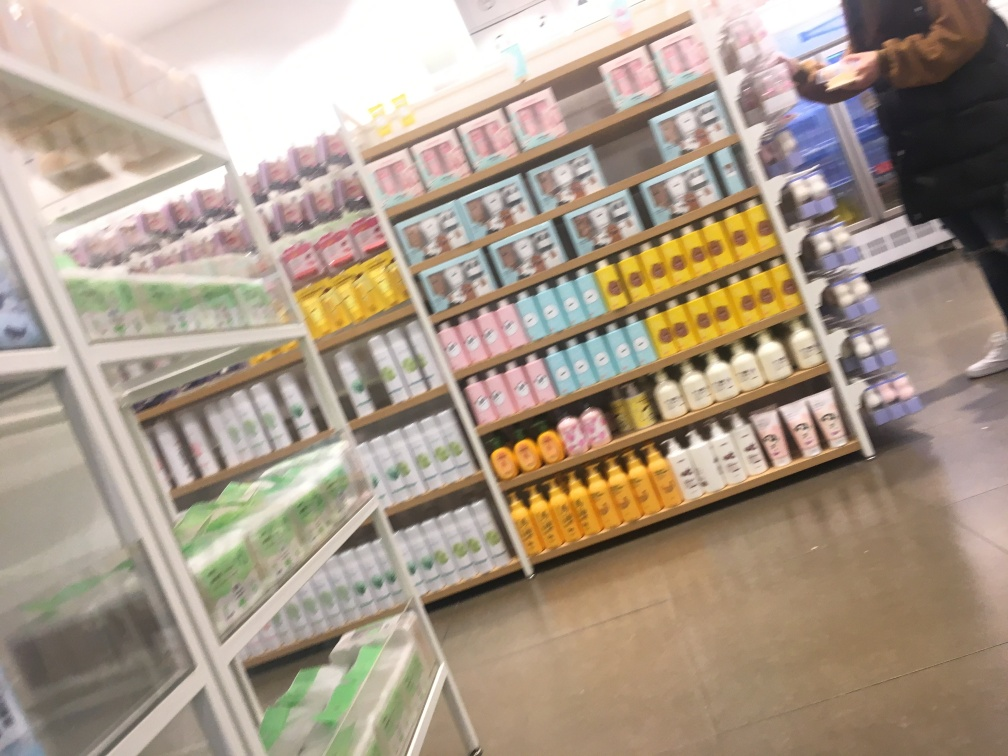What kind of store does this image depict? The image seems to show the interior of a retail store specializing in personal care or cosmetic products, given the arranged shelves with numerous colorful packages often associated with such items. Are there any specific products that are identifiable? Due to the blurriness of the image, it's challenging to identify specific products or brands, as the text and finer details are not sharp enough to read clearly. 